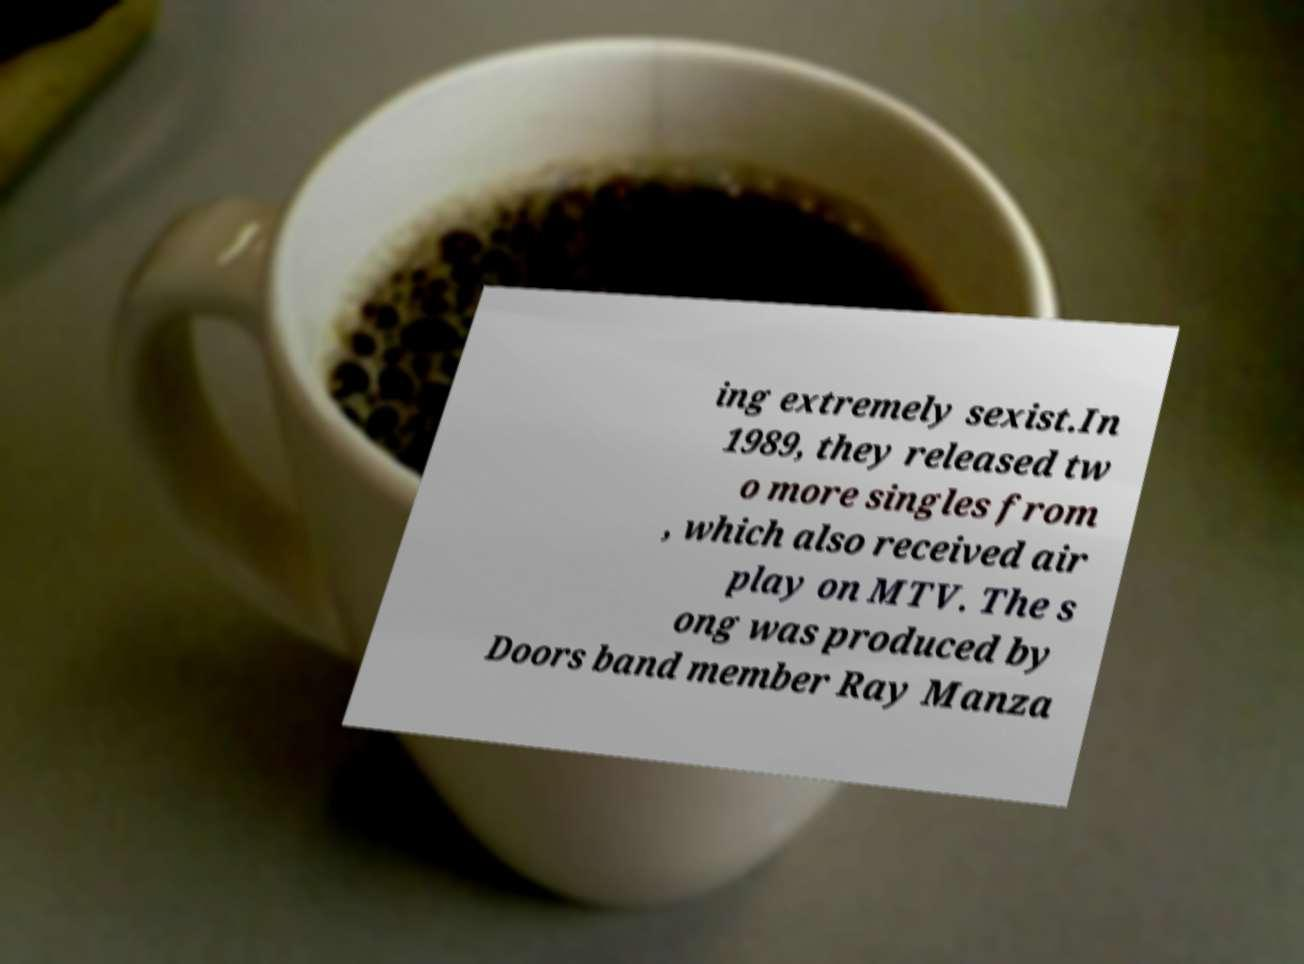Could you extract and type out the text from this image? ing extremely sexist.In 1989, they released tw o more singles from , which also received air play on MTV. The s ong was produced by Doors band member Ray Manza 